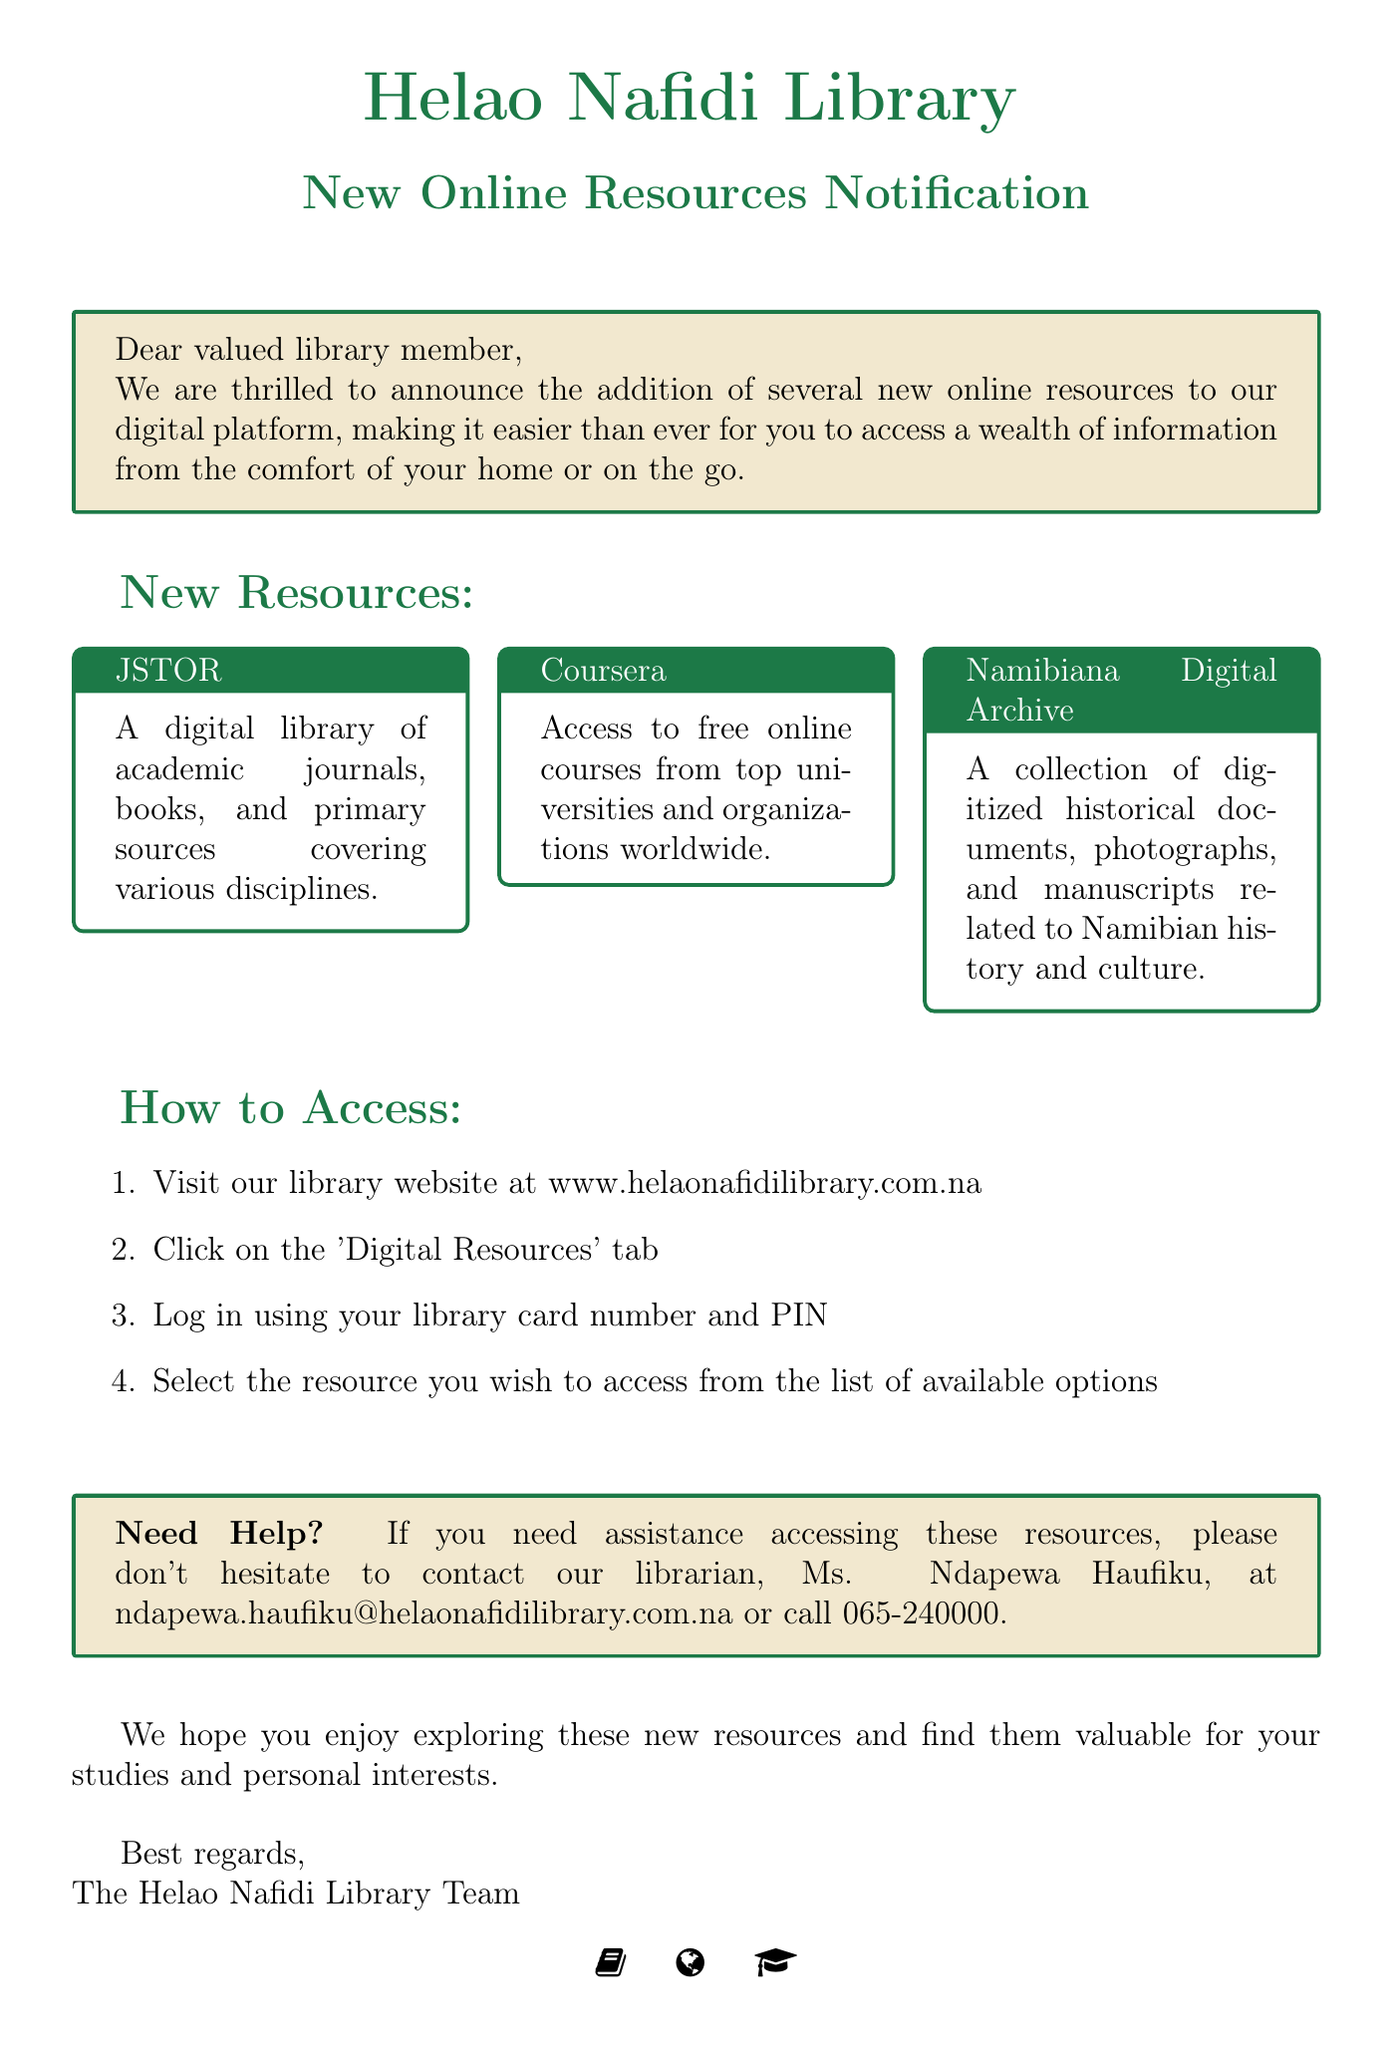What is the subject of the email? The subject of the email is provided at the beginning of the document, which states the topic being discussed.
Answer: Exciting New Online Resources Available at Helao Nafidi Library! Who is the librarian to contact for assistance? The email mentions the librarian's name for any assistance needed regarding the new resources.
Answer: Ms. Ndapewa Haufiku How many new online resources are mentioned? The document lists the new online resources in a specific section, allowing for a straightforward count.
Answer: Three What is one of the new resources offered? The email provides a list of new resources available through the library’s digital platform.
Answer: JSTOR What should library members use to log in to the digital resources? The instructions specify what credentials are required for accessing the digital resources.
Answer: Library card number and PIN What is the website for the Helao Nafidi Library? The email includes the URL for the library's website for accessing the digital resources.
Answer: www.helaonafidilibrary.com.na Which resource focuses on Namibian history and culture? The email describes each resource, making it clear which resource pertains to local history and culture.
Answer: Namibiana Digital Archive What type of courses can users access on Coursera? The description provided in the email specifies the nature of the courses offered through Coursera.
Answer: Free online courses How do you access the digital resources? The email outlines a specific process for accessing the digital resources, which is step-by-step.
Answer: Visit library website, click 'Digital Resources' tab, log in, select resource 